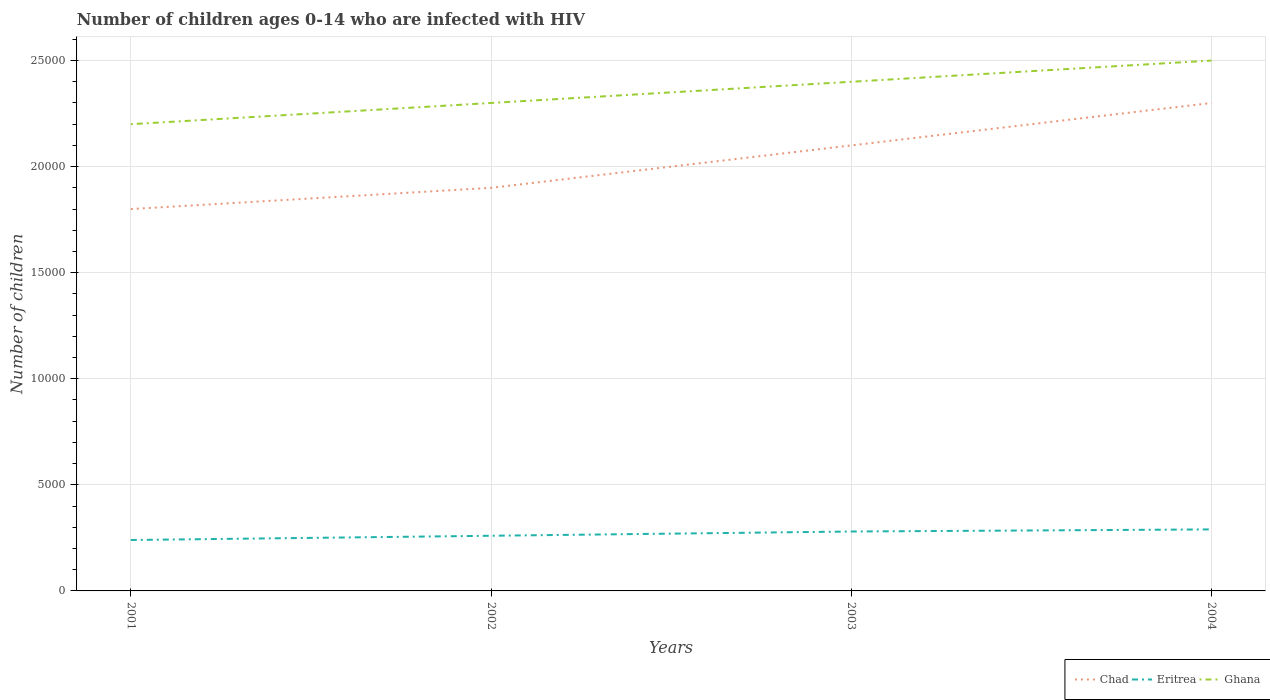Across all years, what is the maximum number of HIV infected children in Eritrea?
Ensure brevity in your answer.  2400. In which year was the number of HIV infected children in Eritrea maximum?
Give a very brief answer. 2001. What is the total number of HIV infected children in Eritrea in the graph?
Your answer should be very brief. -200. What is the difference between the highest and the second highest number of HIV infected children in Ghana?
Ensure brevity in your answer.  3000. Is the number of HIV infected children in Ghana strictly greater than the number of HIV infected children in Chad over the years?
Your answer should be compact. No. How many years are there in the graph?
Offer a terse response. 4. What is the difference between two consecutive major ticks on the Y-axis?
Keep it short and to the point. 5000. Does the graph contain grids?
Provide a succinct answer. Yes. What is the title of the graph?
Give a very brief answer. Number of children ages 0-14 who are infected with HIV. Does "Grenada" appear as one of the legend labels in the graph?
Keep it short and to the point. No. What is the label or title of the X-axis?
Offer a very short reply. Years. What is the label or title of the Y-axis?
Offer a terse response. Number of children. What is the Number of children of Chad in 2001?
Your answer should be very brief. 1.80e+04. What is the Number of children of Eritrea in 2001?
Provide a short and direct response. 2400. What is the Number of children of Ghana in 2001?
Your answer should be compact. 2.20e+04. What is the Number of children in Chad in 2002?
Offer a very short reply. 1.90e+04. What is the Number of children of Eritrea in 2002?
Provide a short and direct response. 2600. What is the Number of children of Ghana in 2002?
Keep it short and to the point. 2.30e+04. What is the Number of children of Chad in 2003?
Offer a terse response. 2.10e+04. What is the Number of children in Eritrea in 2003?
Offer a terse response. 2800. What is the Number of children in Ghana in 2003?
Provide a short and direct response. 2.40e+04. What is the Number of children in Chad in 2004?
Your answer should be very brief. 2.30e+04. What is the Number of children of Eritrea in 2004?
Your answer should be compact. 2900. What is the Number of children of Ghana in 2004?
Ensure brevity in your answer.  2.50e+04. Across all years, what is the maximum Number of children in Chad?
Make the answer very short. 2.30e+04. Across all years, what is the maximum Number of children of Eritrea?
Make the answer very short. 2900. Across all years, what is the maximum Number of children in Ghana?
Make the answer very short. 2.50e+04. Across all years, what is the minimum Number of children of Chad?
Provide a succinct answer. 1.80e+04. Across all years, what is the minimum Number of children in Eritrea?
Give a very brief answer. 2400. Across all years, what is the minimum Number of children of Ghana?
Give a very brief answer. 2.20e+04. What is the total Number of children of Chad in the graph?
Make the answer very short. 8.10e+04. What is the total Number of children of Eritrea in the graph?
Your answer should be very brief. 1.07e+04. What is the total Number of children in Ghana in the graph?
Keep it short and to the point. 9.40e+04. What is the difference between the Number of children in Chad in 2001 and that in 2002?
Make the answer very short. -1000. What is the difference between the Number of children of Eritrea in 2001 and that in 2002?
Your answer should be very brief. -200. What is the difference between the Number of children of Ghana in 2001 and that in 2002?
Your answer should be compact. -1000. What is the difference between the Number of children of Chad in 2001 and that in 2003?
Offer a very short reply. -3000. What is the difference between the Number of children in Eritrea in 2001 and that in 2003?
Offer a very short reply. -400. What is the difference between the Number of children of Ghana in 2001 and that in 2003?
Offer a very short reply. -2000. What is the difference between the Number of children in Chad in 2001 and that in 2004?
Make the answer very short. -5000. What is the difference between the Number of children in Eritrea in 2001 and that in 2004?
Provide a succinct answer. -500. What is the difference between the Number of children of Ghana in 2001 and that in 2004?
Your answer should be compact. -3000. What is the difference between the Number of children in Chad in 2002 and that in 2003?
Give a very brief answer. -2000. What is the difference between the Number of children in Eritrea in 2002 and that in 2003?
Provide a succinct answer. -200. What is the difference between the Number of children in Ghana in 2002 and that in 2003?
Provide a short and direct response. -1000. What is the difference between the Number of children in Chad in 2002 and that in 2004?
Provide a succinct answer. -4000. What is the difference between the Number of children of Eritrea in 2002 and that in 2004?
Keep it short and to the point. -300. What is the difference between the Number of children in Ghana in 2002 and that in 2004?
Your response must be concise. -2000. What is the difference between the Number of children in Chad in 2003 and that in 2004?
Provide a short and direct response. -2000. What is the difference between the Number of children in Eritrea in 2003 and that in 2004?
Ensure brevity in your answer.  -100. What is the difference between the Number of children in Ghana in 2003 and that in 2004?
Make the answer very short. -1000. What is the difference between the Number of children of Chad in 2001 and the Number of children of Eritrea in 2002?
Offer a terse response. 1.54e+04. What is the difference between the Number of children of Chad in 2001 and the Number of children of Ghana in 2002?
Provide a short and direct response. -5000. What is the difference between the Number of children in Eritrea in 2001 and the Number of children in Ghana in 2002?
Offer a very short reply. -2.06e+04. What is the difference between the Number of children in Chad in 2001 and the Number of children in Eritrea in 2003?
Your response must be concise. 1.52e+04. What is the difference between the Number of children of Chad in 2001 and the Number of children of Ghana in 2003?
Give a very brief answer. -6000. What is the difference between the Number of children of Eritrea in 2001 and the Number of children of Ghana in 2003?
Your response must be concise. -2.16e+04. What is the difference between the Number of children in Chad in 2001 and the Number of children in Eritrea in 2004?
Offer a terse response. 1.51e+04. What is the difference between the Number of children in Chad in 2001 and the Number of children in Ghana in 2004?
Offer a terse response. -7000. What is the difference between the Number of children in Eritrea in 2001 and the Number of children in Ghana in 2004?
Ensure brevity in your answer.  -2.26e+04. What is the difference between the Number of children in Chad in 2002 and the Number of children in Eritrea in 2003?
Ensure brevity in your answer.  1.62e+04. What is the difference between the Number of children of Chad in 2002 and the Number of children of Ghana in 2003?
Provide a succinct answer. -5000. What is the difference between the Number of children of Eritrea in 2002 and the Number of children of Ghana in 2003?
Your answer should be compact. -2.14e+04. What is the difference between the Number of children of Chad in 2002 and the Number of children of Eritrea in 2004?
Make the answer very short. 1.61e+04. What is the difference between the Number of children in Chad in 2002 and the Number of children in Ghana in 2004?
Keep it short and to the point. -6000. What is the difference between the Number of children of Eritrea in 2002 and the Number of children of Ghana in 2004?
Ensure brevity in your answer.  -2.24e+04. What is the difference between the Number of children in Chad in 2003 and the Number of children in Eritrea in 2004?
Offer a terse response. 1.81e+04. What is the difference between the Number of children in Chad in 2003 and the Number of children in Ghana in 2004?
Provide a short and direct response. -4000. What is the difference between the Number of children in Eritrea in 2003 and the Number of children in Ghana in 2004?
Your answer should be very brief. -2.22e+04. What is the average Number of children in Chad per year?
Keep it short and to the point. 2.02e+04. What is the average Number of children in Eritrea per year?
Ensure brevity in your answer.  2675. What is the average Number of children of Ghana per year?
Give a very brief answer. 2.35e+04. In the year 2001, what is the difference between the Number of children of Chad and Number of children of Eritrea?
Your answer should be very brief. 1.56e+04. In the year 2001, what is the difference between the Number of children in Chad and Number of children in Ghana?
Your answer should be compact. -4000. In the year 2001, what is the difference between the Number of children of Eritrea and Number of children of Ghana?
Your answer should be very brief. -1.96e+04. In the year 2002, what is the difference between the Number of children in Chad and Number of children in Eritrea?
Keep it short and to the point. 1.64e+04. In the year 2002, what is the difference between the Number of children in Chad and Number of children in Ghana?
Your answer should be compact. -4000. In the year 2002, what is the difference between the Number of children of Eritrea and Number of children of Ghana?
Your answer should be compact. -2.04e+04. In the year 2003, what is the difference between the Number of children of Chad and Number of children of Eritrea?
Your answer should be compact. 1.82e+04. In the year 2003, what is the difference between the Number of children of Chad and Number of children of Ghana?
Your answer should be compact. -3000. In the year 2003, what is the difference between the Number of children of Eritrea and Number of children of Ghana?
Keep it short and to the point. -2.12e+04. In the year 2004, what is the difference between the Number of children in Chad and Number of children in Eritrea?
Provide a short and direct response. 2.01e+04. In the year 2004, what is the difference between the Number of children in Chad and Number of children in Ghana?
Give a very brief answer. -2000. In the year 2004, what is the difference between the Number of children of Eritrea and Number of children of Ghana?
Give a very brief answer. -2.21e+04. What is the ratio of the Number of children of Chad in 2001 to that in 2002?
Your response must be concise. 0.95. What is the ratio of the Number of children of Eritrea in 2001 to that in 2002?
Your answer should be compact. 0.92. What is the ratio of the Number of children of Ghana in 2001 to that in 2002?
Offer a very short reply. 0.96. What is the ratio of the Number of children of Chad in 2001 to that in 2003?
Your response must be concise. 0.86. What is the ratio of the Number of children of Eritrea in 2001 to that in 2003?
Give a very brief answer. 0.86. What is the ratio of the Number of children in Ghana in 2001 to that in 2003?
Offer a terse response. 0.92. What is the ratio of the Number of children of Chad in 2001 to that in 2004?
Ensure brevity in your answer.  0.78. What is the ratio of the Number of children in Eritrea in 2001 to that in 2004?
Keep it short and to the point. 0.83. What is the ratio of the Number of children of Ghana in 2001 to that in 2004?
Ensure brevity in your answer.  0.88. What is the ratio of the Number of children in Chad in 2002 to that in 2003?
Offer a very short reply. 0.9. What is the ratio of the Number of children of Chad in 2002 to that in 2004?
Ensure brevity in your answer.  0.83. What is the ratio of the Number of children in Eritrea in 2002 to that in 2004?
Offer a terse response. 0.9. What is the ratio of the Number of children of Chad in 2003 to that in 2004?
Provide a short and direct response. 0.91. What is the ratio of the Number of children in Eritrea in 2003 to that in 2004?
Offer a very short reply. 0.97. What is the ratio of the Number of children in Ghana in 2003 to that in 2004?
Offer a very short reply. 0.96. What is the difference between the highest and the lowest Number of children in Chad?
Make the answer very short. 5000. What is the difference between the highest and the lowest Number of children in Ghana?
Your answer should be very brief. 3000. 